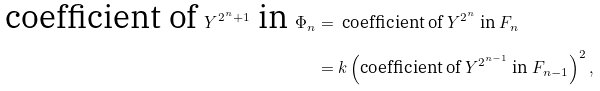<formula> <loc_0><loc_0><loc_500><loc_500>\text { coefficient of } Y ^ { 2 ^ { n } + 1 } \text { in } \Phi _ { n } & = \text { coefficient of } Y ^ { 2 ^ { n } } \text { in } F _ { n } \\ & = k \left ( \text {coefficient of } Y ^ { 2 ^ { n - 1 } } \text { in } F _ { n - 1 } \right ) ^ { 2 } ,</formula> 